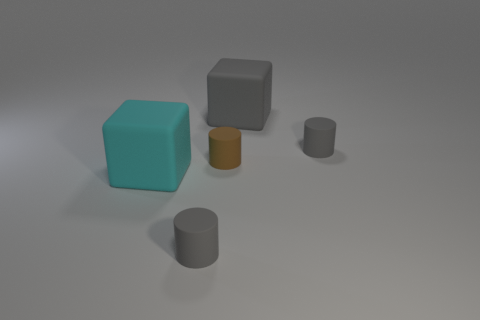The brown object that is made of the same material as the cyan thing is what shape?
Give a very brief answer. Cylinder. Is there a big green shiny object?
Offer a very short reply. No. Are there any gray rubber blocks to the left of the tiny thing that is in front of the cyan rubber thing?
Provide a succinct answer. No. What material is the cyan thing that is the same shape as the large gray thing?
Give a very brief answer. Rubber. Are there more gray cylinders than red rubber cylinders?
Give a very brief answer. Yes. What color is the matte thing that is both in front of the tiny brown matte thing and right of the cyan thing?
Your answer should be compact. Gray. How many other things are there of the same material as the cyan block?
Your answer should be compact. 4. Is the number of small brown matte cylinders less than the number of small matte cylinders?
Provide a succinct answer. Yes. Is the material of the large cyan cube the same as the tiny gray object to the left of the brown matte thing?
Provide a succinct answer. Yes. What is the shape of the big thing that is on the left side of the large gray block?
Make the answer very short. Cube. 